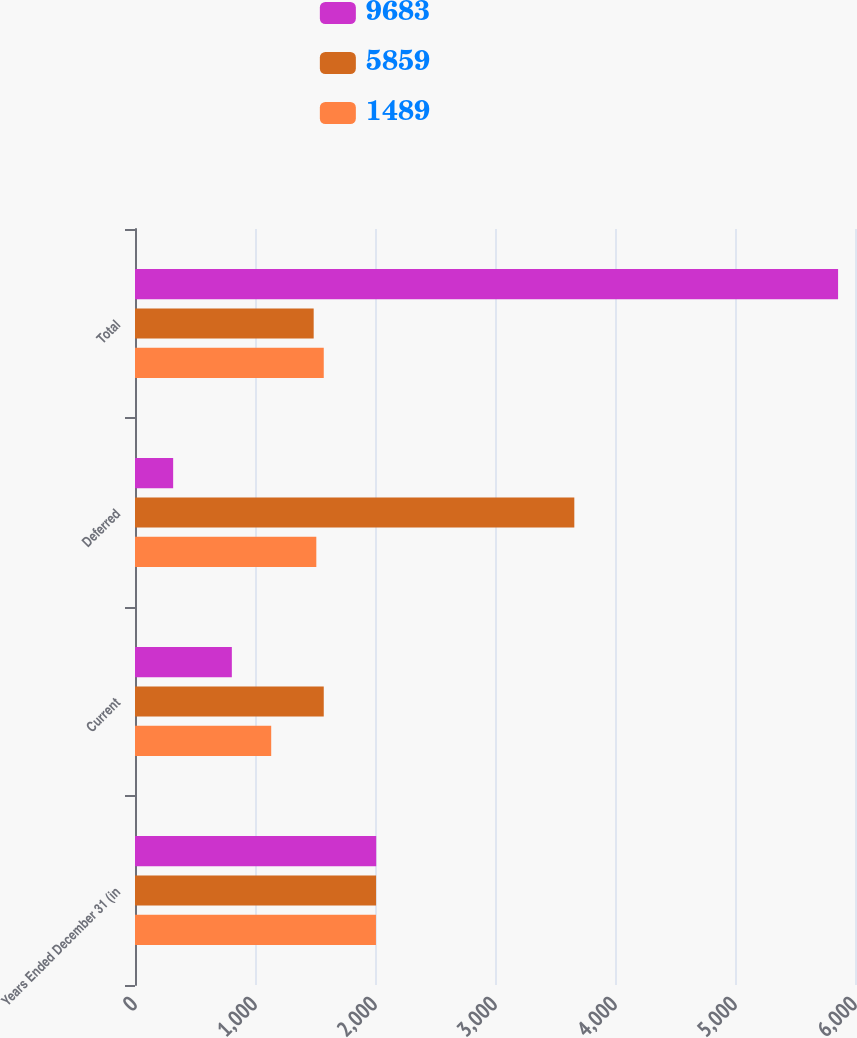<chart> <loc_0><loc_0><loc_500><loc_500><stacked_bar_chart><ecel><fcel>Years Ended December 31 (in<fcel>Current<fcel>Deferred<fcel>Total<nl><fcel>9683<fcel>2010<fcel>807<fcel>318<fcel>5859<nl><fcel>5859<fcel>2009<fcel>1573<fcel>3661<fcel>1489<nl><fcel>1489<fcel>2008<fcel>1135<fcel>1511<fcel>1573<nl></chart> 